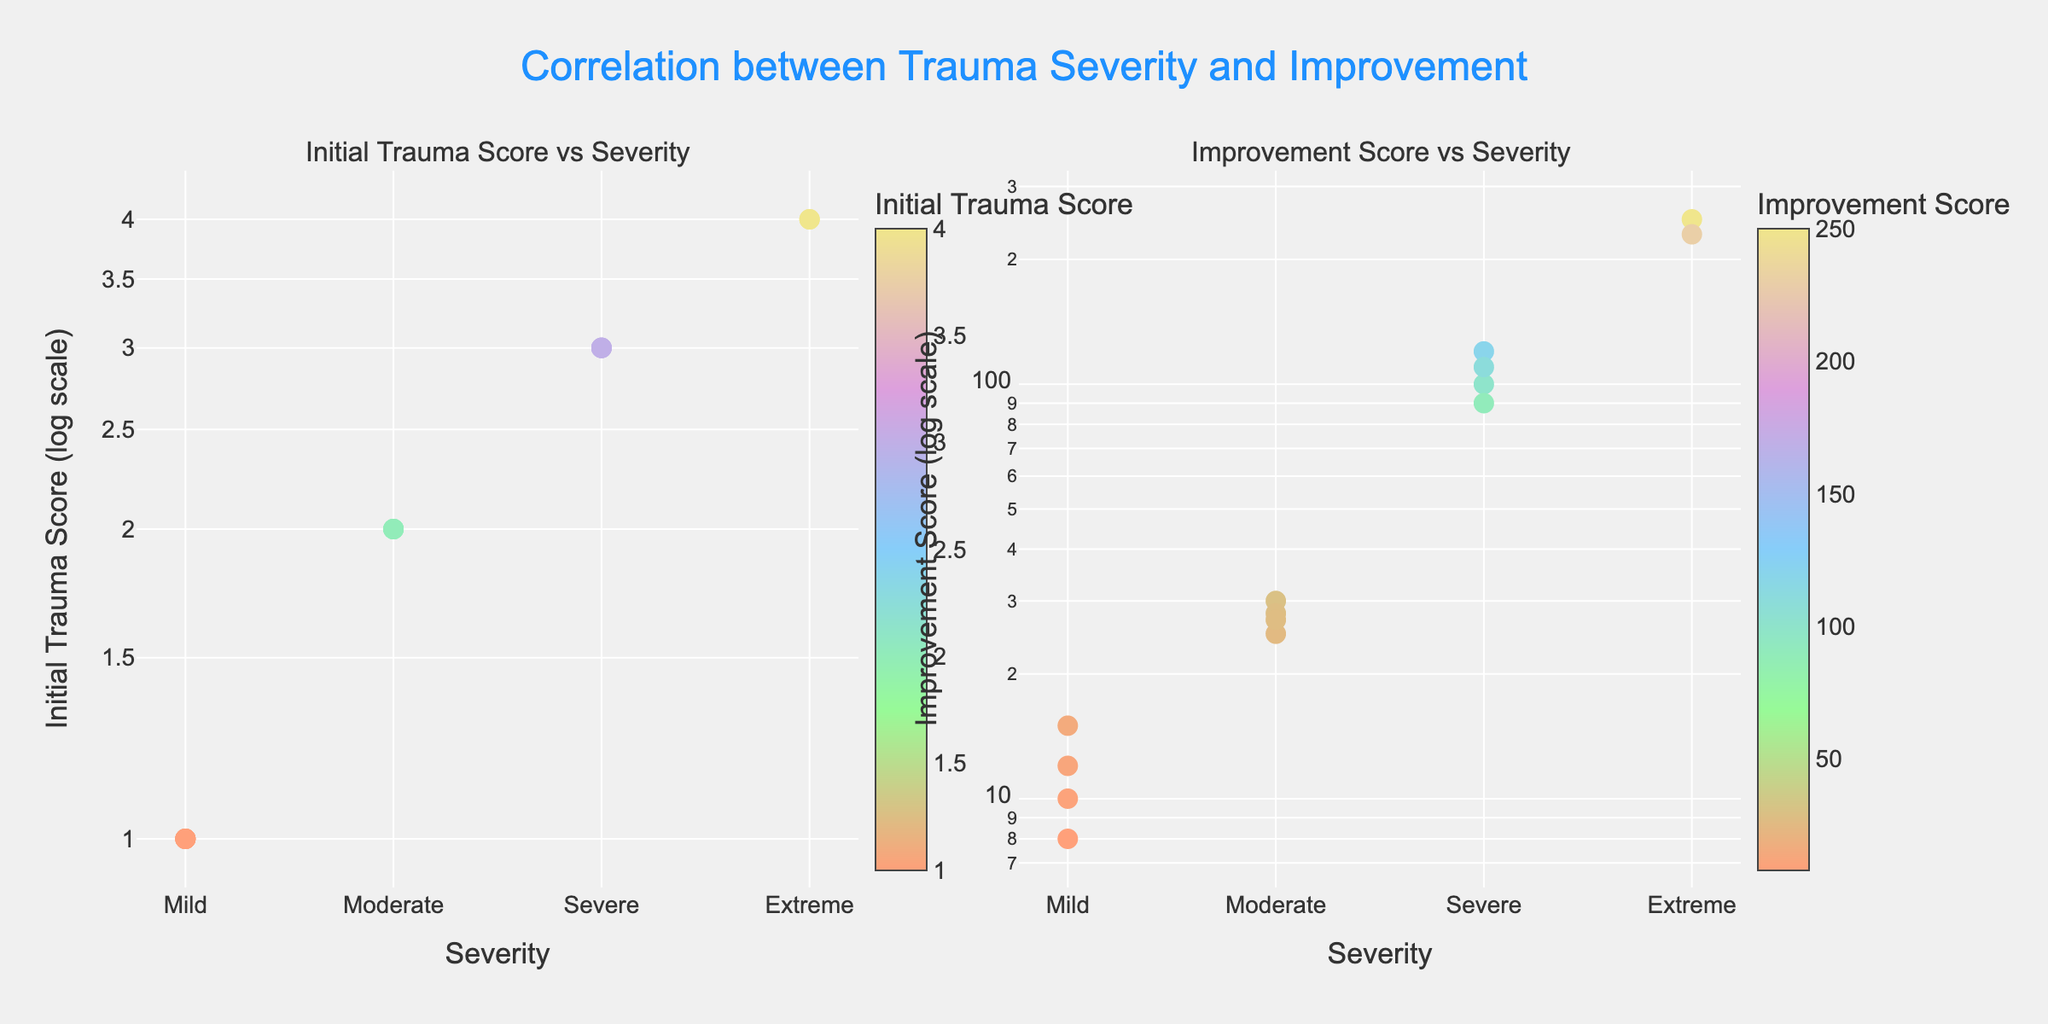What is the title of the figure? The title is located at the top center of the figure and provides an overview of what the figure represents. Reading the title provides context for understanding the data.
Answer: Correlation between Trauma Severity and Improvement How many data points are there in total? By counting the number of markers in both subplots, we can determine the total number of data points.
Answer: 14 What colors are used to represent the markers in the figure? The colors of the markers range across a spectrum as shown in the figure's color scale bars. The question can be answered by identifying these color ranges visually.
Answer: Light pink, light green, light blue, light purple, light yellow What severity level shows the highest improvement score? By examining the Improvement Score vs Severity subplot, you can see which severity level corresponds to the highest position on the y-axis.
Answer: Extreme Does the severity class "Mild" have higher initial trauma scores or improvement scores on average? First, we identify the "Mild" data points. Then, we can visually compare the average initial trauma scores and improvement scores in their respective subplots.
Answer: Improvement scores What is the range of initial trauma scores for the "Moderate" severity class? By looking at the Initial Trauma Score vs Severity subplot, identify the range of y-values corresponding to the "Moderate" severity class.
Answer: From 2 to 2 Which subplot demonstrates a more significant variation in scores? Observing the vertical spread of data points in each subplot, we can determine which set of scores is more varied.
Answer: Improvement Score vs Severity Does higher initial trauma severity correlate with higher improvement scores? By comparing the trends in both subplots, we can assess if higher initial trauma severity levels generally lead to higher improvement scores.
Answer: Yes How does the data distribution for the "Severe" severity class compare between initial trauma and improvement scores? Look at the scatter of data points labeled "Severe" in both subplots. Check if the spread and central tendencies are similar or different.
Answer: More varied in improvement scores On the logarithmic scale, what is the approximate range of improvement scores for the "Extreme" severity class? Identify the data points in the Improvement Score vs Severity subplot that belong to the "Extreme" category, then determine the spread of their positions on the log scale.
Answer: From 230 to 250 